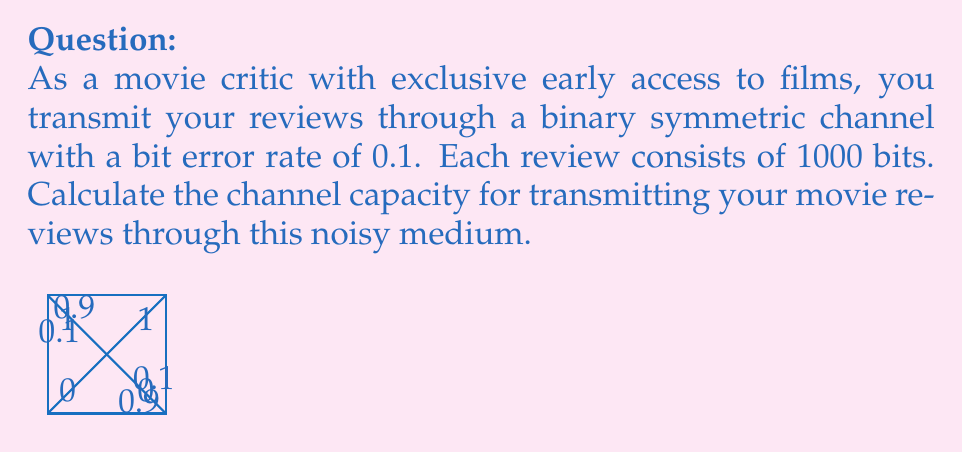Can you answer this question? To solve this problem, we'll use the formula for the capacity of a binary symmetric channel:

1. The capacity of a binary symmetric channel is given by:
   $$C = 1 - H(p)$$
   where $H(p)$ is the binary entropy function and $p$ is the bit error rate.

2. The binary entropy function is defined as:
   $$H(p) = -p \log_2(p) - (1-p) \log_2(1-p)$$

3. Given: 
   - Bit error rate $p = 0.1$
   - Each review is 1000 bits long

4. Calculate $H(0.1)$:
   $$H(0.1) = -0.1 \log_2(0.1) - 0.9 \log_2(0.9)$$
   $$\approx 0.1 \cdot 3.32 + 0.9 \cdot 0.15$$
   $$\approx 0.332 + 0.135 = 0.467$$

5. Now we can calculate the channel capacity:
   $$C = 1 - H(0.1) = 1 - 0.467 = 0.533$$

6. This capacity is in bits per channel use. To get the capacity for the entire 1000-bit review:
   $$C_{total} = 1000 \cdot 0.533 = 533\text{ bits}$$

Therefore, the channel capacity for transmitting your 1000-bit movie review through this noisy medium is approximately 533 bits.
Answer: 533 bits 